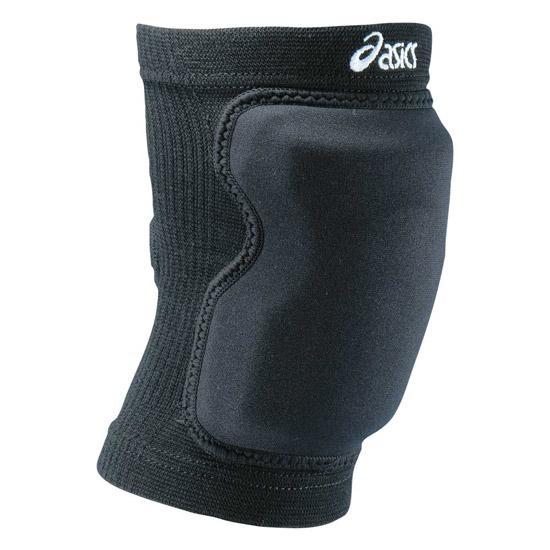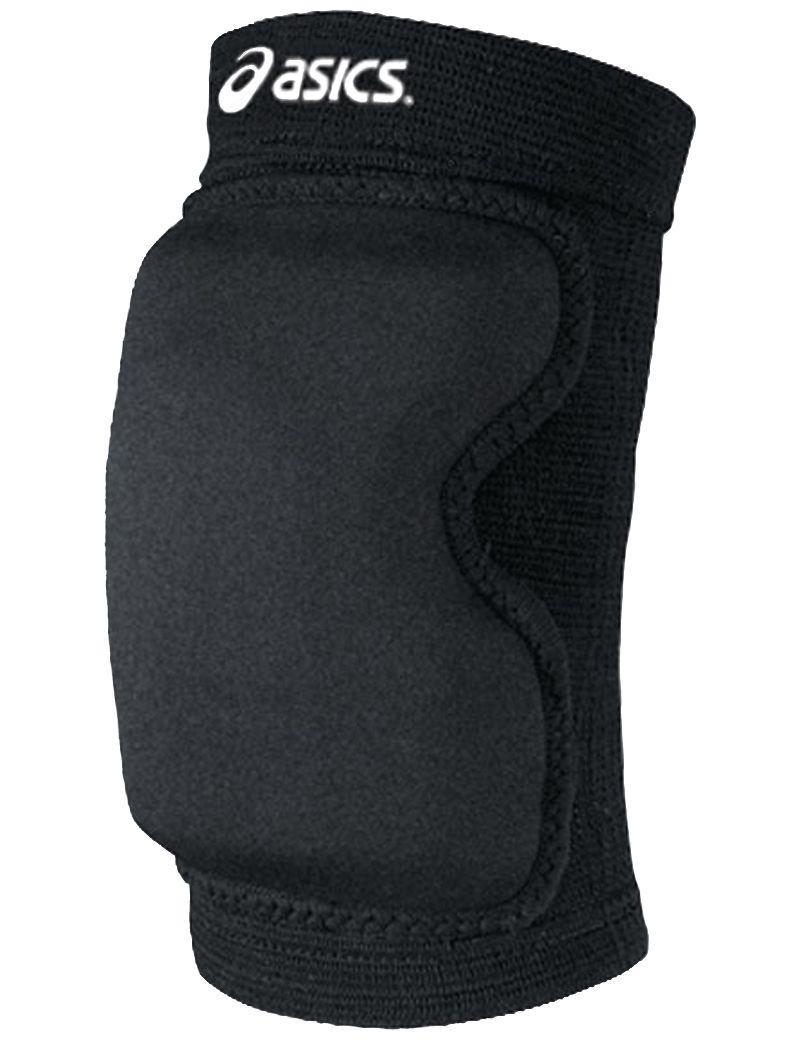The first image is the image on the left, the second image is the image on the right. Assess this claim about the two images: "There are two kneepads in total". Correct or not? Answer yes or no. Yes. 